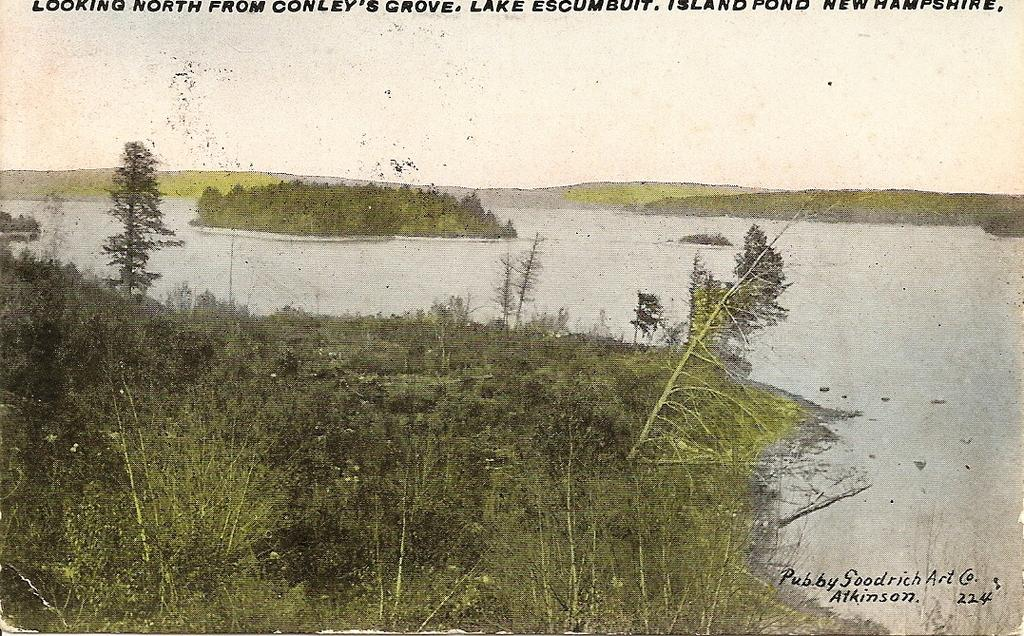What is located in the front of the image? There are plants in the front of the image. What is in the center of the image? There is water in the center of the image. What can be seen in the background of the image? There are plants and grass in the background of the image. What type of business is being conducted in the image? There is no indication of a business in the image; it primarily features plants, water, and grass. Is there any visible pollution in the image? There is no visible pollution in the image; it appears to be a natural scene with plants, water, and grass. 